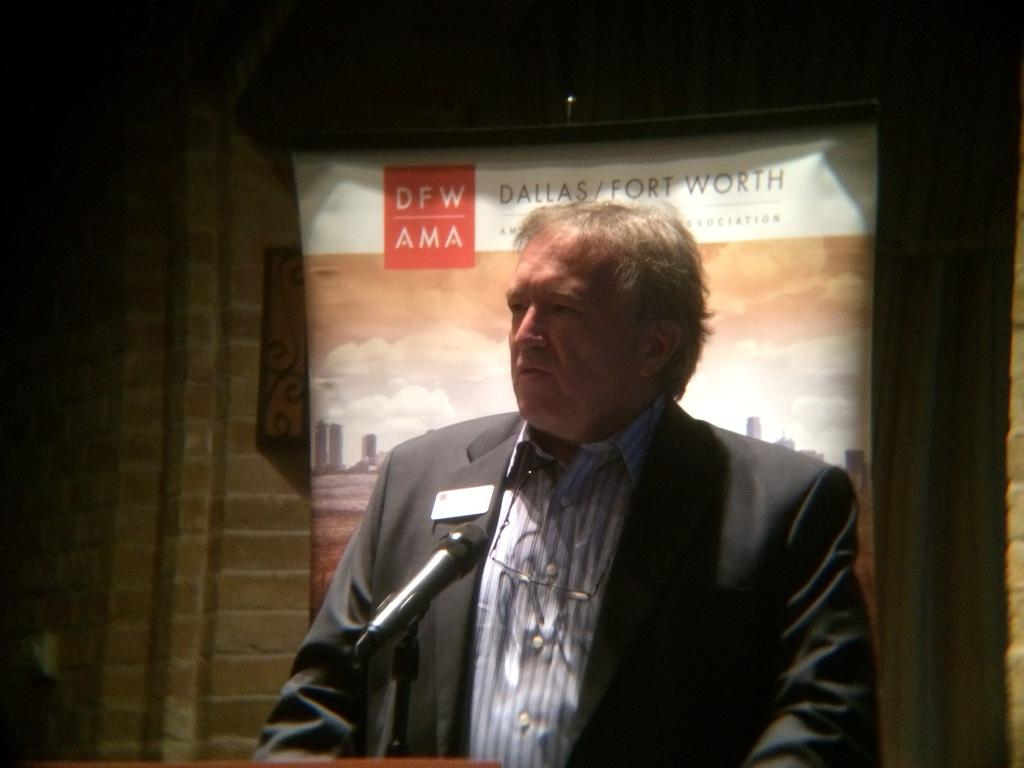What is the main subject in the foreground of the picture? There is a person in the foreground of the picture. What is the person wearing? The person is wearing a suit. What is the person holding in the picture? The person is holding a mic. What can be seen in the background of the picture? There is a banner and a wall in the background of the picture. How many babies are visible in the picture? There are no babies present in the picture. What type of doctor is standing next to the person holding the mic? There is no doctor present in the picture. 